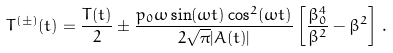<formula> <loc_0><loc_0><loc_500><loc_500>T ^ { ( \pm ) } ( t ) = \frac { T ( t ) } { 2 } \pm \frac { p _ { 0 } \omega \sin ( \omega t ) \cos ^ { 2 } ( \omega t ) } { 2 \sqrt { \pi } | A ( t ) | } \left [ \frac { \beta _ { 0 } ^ { 4 } } { \beta ^ { 2 } } - \beta ^ { 2 } \right ] \, .</formula> 